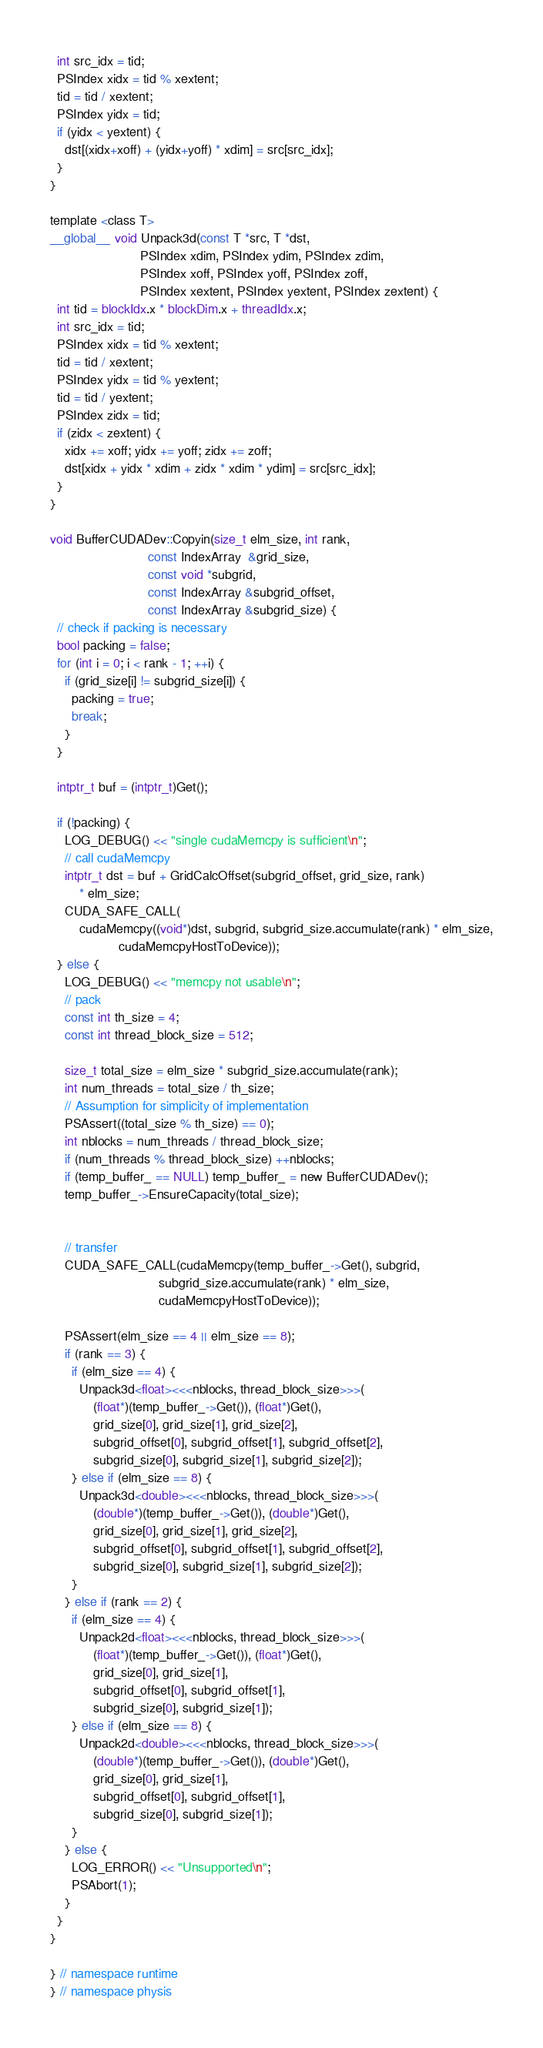Convert code to text. <code><loc_0><loc_0><loc_500><loc_500><_Cuda_>  int src_idx = tid;
  PSIndex xidx = tid % xextent;
  tid = tid / xextent;
  PSIndex yidx = tid;
  if (yidx < yextent) {
    dst[(xidx+xoff) + (yidx+yoff) * xdim] = src[src_idx];
  }
}

template <class T>
__global__ void Unpack3d(const T *src, T *dst,
                         PSIndex xdim, PSIndex ydim, PSIndex zdim,
                         PSIndex xoff, PSIndex yoff, PSIndex zoff,
                         PSIndex xextent, PSIndex yextent, PSIndex zextent) {
  int tid = blockIdx.x * blockDim.x + threadIdx.x;
  int src_idx = tid;
  PSIndex xidx = tid % xextent;
  tid = tid / xextent;
  PSIndex yidx = tid % yextent;
  tid = tid / yextent;
  PSIndex zidx = tid;
  if (zidx < zextent) {
    xidx += xoff; yidx += yoff; zidx += zoff;
    dst[xidx + yidx * xdim + zidx * xdim * ydim] = src[src_idx];
  }
}

void BufferCUDADev::Copyin(size_t elm_size, int rank,
                           const IndexArray  &grid_size,
                           const void *subgrid,
                           const IndexArray &subgrid_offset,
                           const IndexArray &subgrid_size) {
  // check if packing is necessary
  bool packing = false;
  for (int i = 0; i < rank - 1; ++i) {
    if (grid_size[i] != subgrid_size[i]) {
      packing = true;
      break;
    }
  }

  intptr_t buf = (intptr_t)Get();
  
  if (!packing) {
    LOG_DEBUG() << "single cudaMemcpy is sufficient\n";    
    // call cudaMemcpy
    intptr_t dst = buf + GridCalcOffset(subgrid_offset, grid_size, rank)
        * elm_size;
    CUDA_SAFE_CALL(
        cudaMemcpy((void*)dst, subgrid, subgrid_size.accumulate(rank) * elm_size,
                   cudaMemcpyHostToDevice));
  } else {
    LOG_DEBUG() << "memcpy not usable\n";
    // pack
    const int th_size = 4;
    const int thread_block_size = 512;
  
    size_t total_size = elm_size * subgrid_size.accumulate(rank);
    int num_threads = total_size / th_size;
    // Assumption for simplicity of implementation
    PSAssert((total_size % th_size) == 0);
    int nblocks = num_threads / thread_block_size;
    if (num_threads % thread_block_size) ++nblocks;
    if (temp_buffer_ == NULL) temp_buffer_ = new BufferCUDADev();
    temp_buffer_->EnsureCapacity(total_size);


    // transfer
    CUDA_SAFE_CALL(cudaMemcpy(temp_buffer_->Get(), subgrid, 
                              subgrid_size.accumulate(rank) * elm_size,
                              cudaMemcpyHostToDevice));

    PSAssert(elm_size == 4 || elm_size == 8);
    if (rank == 3) {
      if (elm_size == 4) {
        Unpack3d<float><<<nblocks, thread_block_size>>>(
            (float*)(temp_buffer_->Get()), (float*)Get(),
            grid_size[0], grid_size[1], grid_size[2],
            subgrid_offset[0], subgrid_offset[1], subgrid_offset[2],
            subgrid_size[0], subgrid_size[1], subgrid_size[2]);
      } else if (elm_size == 8) {
        Unpack3d<double><<<nblocks, thread_block_size>>>(
            (double*)(temp_buffer_->Get()), (double*)Get(),
            grid_size[0], grid_size[1], grid_size[2],
            subgrid_offset[0], subgrid_offset[1], subgrid_offset[2],
            subgrid_size[0], subgrid_size[1], subgrid_size[2]);
      }        
    } else if (rank == 2) {
      if (elm_size == 4) {
        Unpack2d<float><<<nblocks, thread_block_size>>>(
            (float*)(temp_buffer_->Get()), (float*)Get(), 
            grid_size[0], grid_size[1], 
            subgrid_offset[0], subgrid_offset[1],
            subgrid_size[0], subgrid_size[1]);
      } else if (elm_size == 8) {
        Unpack2d<double><<<nblocks, thread_block_size>>>(
            (double*)(temp_buffer_->Get()), (double*)Get(), 
            grid_size[0], grid_size[1], 
            subgrid_offset[0], subgrid_offset[1],
            subgrid_size[0], subgrid_size[1]);
      }
    } else {
      LOG_ERROR() << "Unsupported\n";
      PSAbort(1);
    }
  }
}

} // namespace runtime
} // namespace physis
</code> 